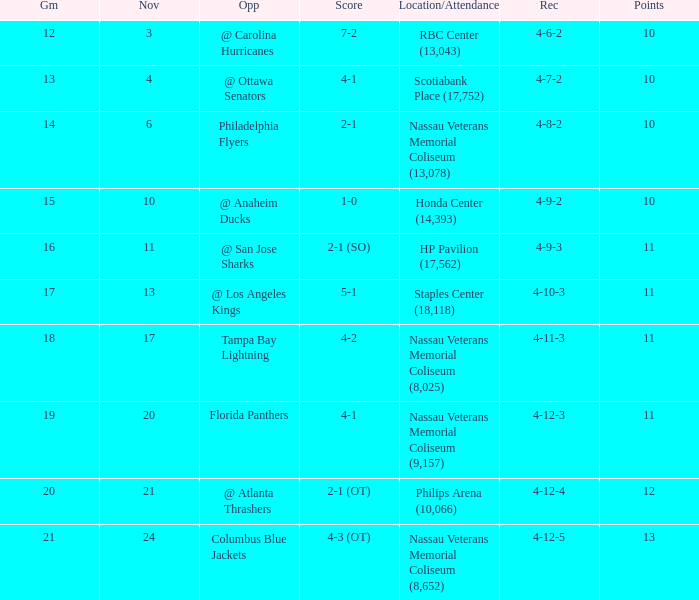What is the highest amount of points? 13.0. 